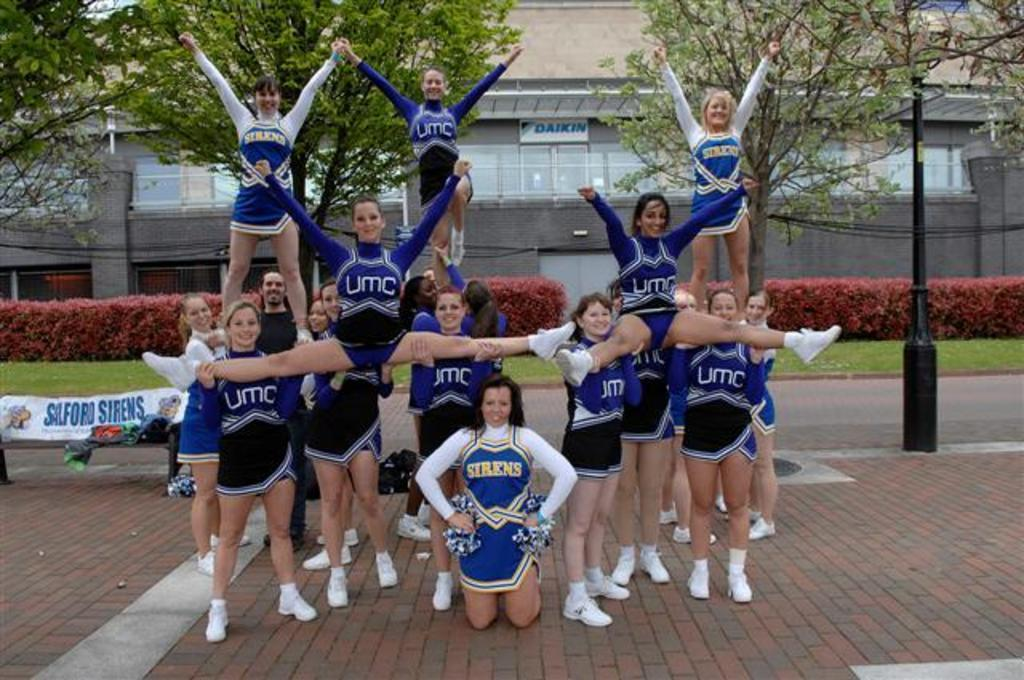<image>
Describe the image concisely. A group of cheerleaders are posing and their uniforms say Sirens and UMC. 